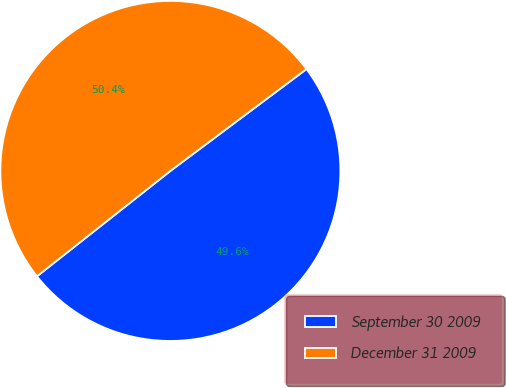<chart> <loc_0><loc_0><loc_500><loc_500><pie_chart><fcel>September 30 2009<fcel>December 31 2009<nl><fcel>49.59%<fcel>50.41%<nl></chart> 